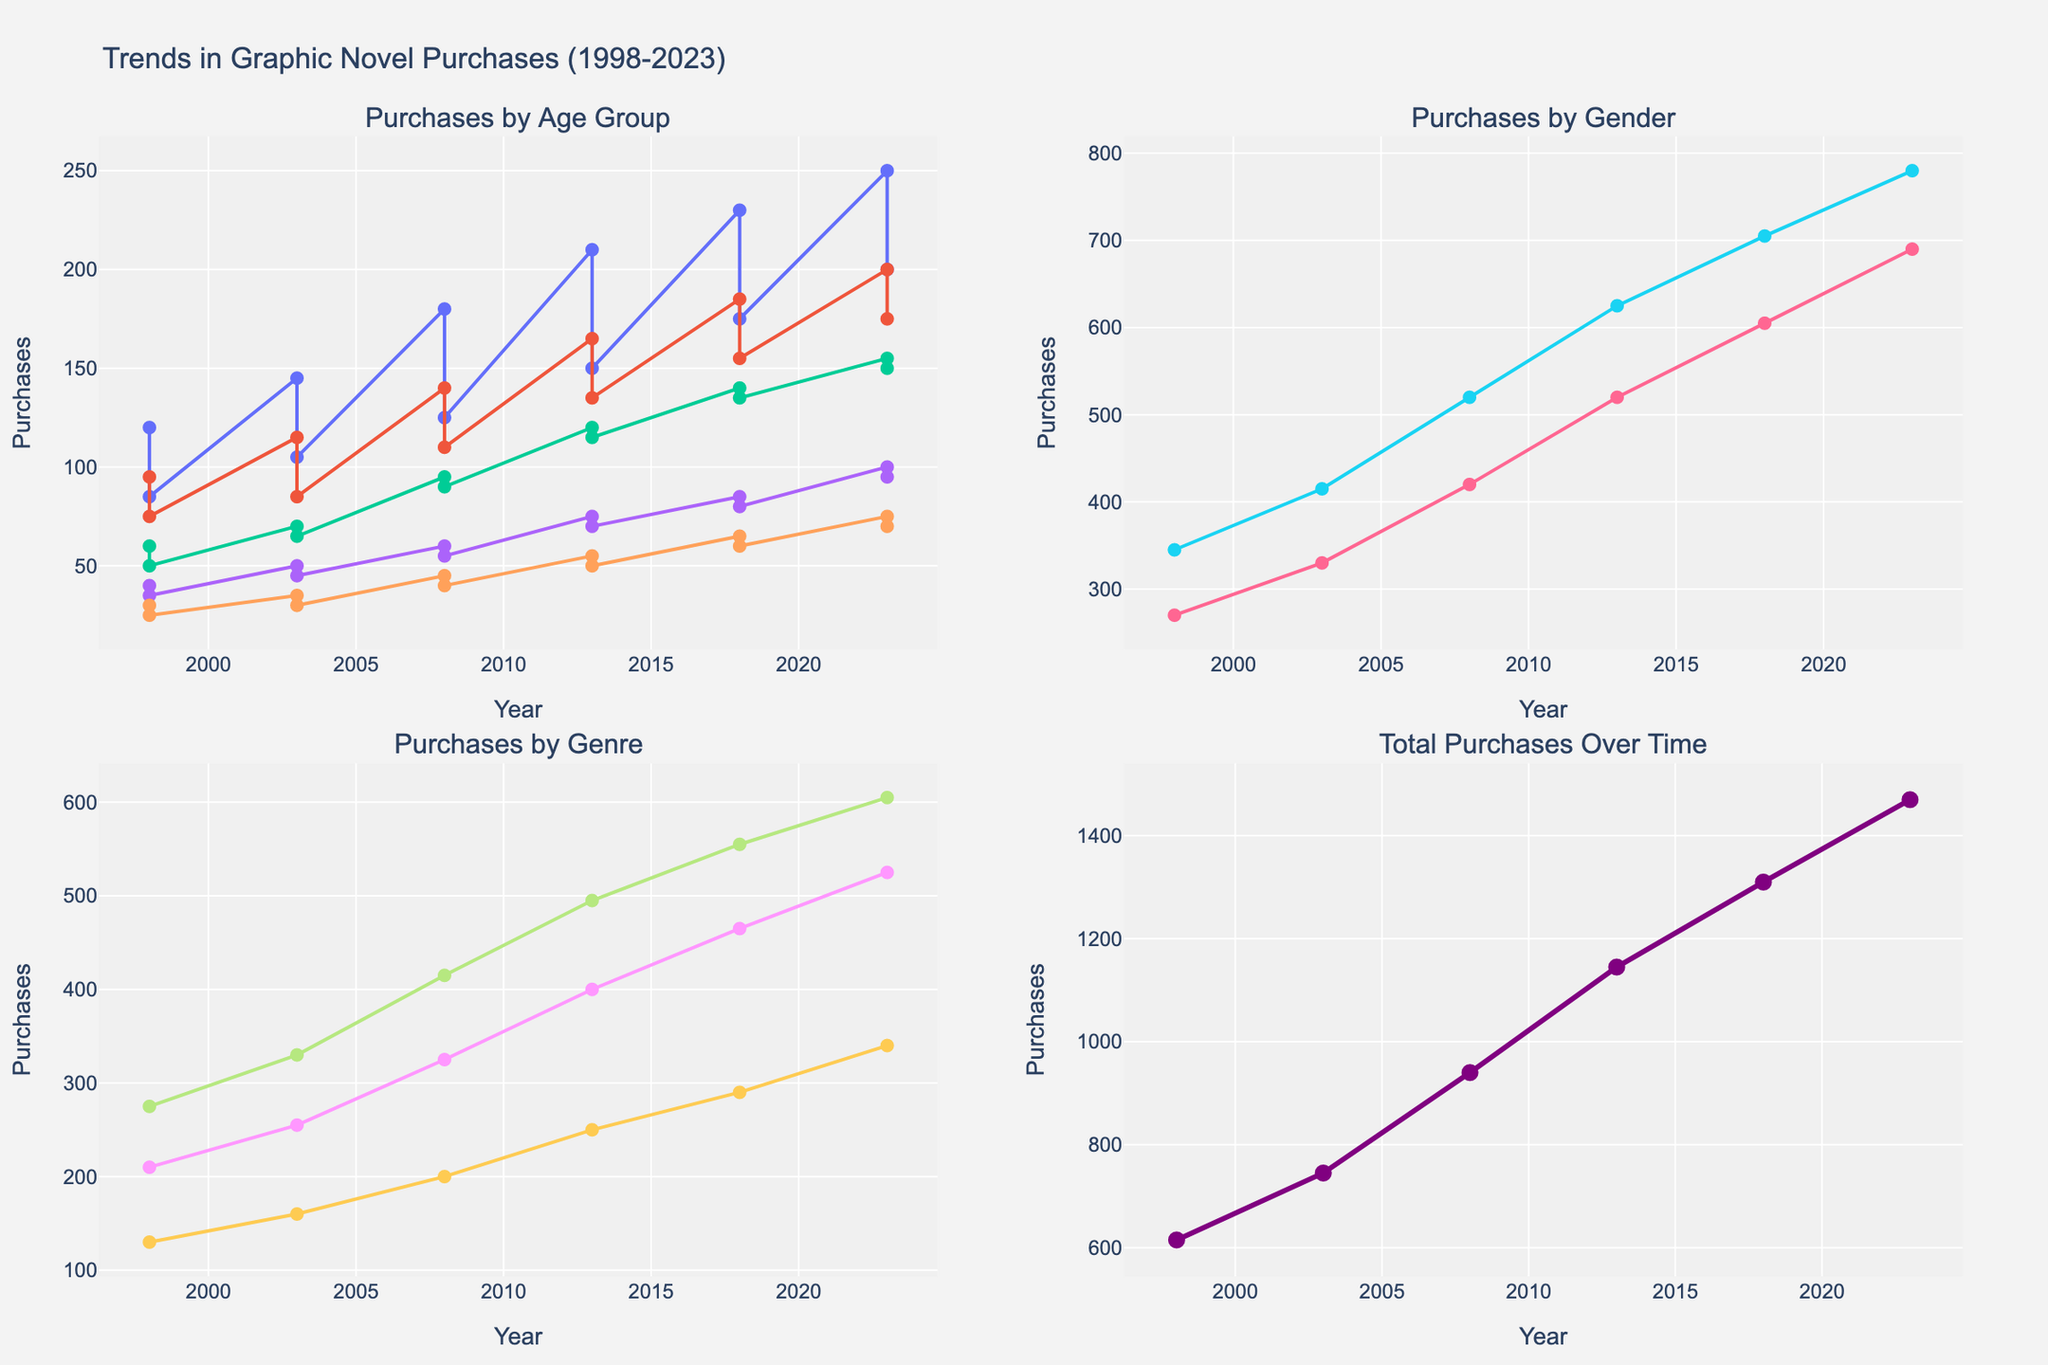What is the title of the figure? Look at the top of the figure where the main title is usually located. It will summarize the content of the visualization.
Answer: Trends in Graphic Novel Purchases (1998-2023) Which age group had the highest purchases in 2023? Locate the subplot titled "Purchases by Age Group" and look at the data points for the year 2023. Identify which age group’s line is at the highest point.
Answer: Under 18 What is the trend for total graphic novel purchases over the years? Observe the subplot titled "Total Purchases Over Time." Examine the line from left to right to see if it generally goes upward, downward, or stays the same.
Answer: Upward trend Compare the total purchases by gender in 2018. Look at the subplot titled "Purchases by Gender" and find the data points for 2018. Compare the y-values for Male and Female.
Answer: Males have higher purchases How have purchases by females changed from 1998 to 2023? Locate the subplot titled "Purchases by Gender" and find the data points for Females in 1998 and 2023. Observe the change in the y-value between these years.
Answer: Increased Which genre saw the most significant growth from 1998 to 2023? Look at the subplot titled "Purchases by Genre" and compare the starting and ending y-values of each genre's trend line. The genre with the largest increase represents the most significant growth.
Answer: Manga What's the average number of purchases for the age group 35-44 over the entire time series? Find the subplot titled "Purchases by Age Group" and focus on the line representing the 35-44 age group. Note down each data point's y-value and calculate the arithmetic mean.
Answer: (40 + 50 + 60 + 75 + 85 + 100)/6 = 68.33 Which age group shows the least variation in purchases over time? Examine the subplot titled "Purchases by Age Group" and observe each group's trend line. Identify the line that appears the most stable with minor fluctuations.
Answer: 45+ 